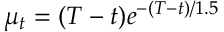<formula> <loc_0><loc_0><loc_500><loc_500>\mu _ { t } = ( T - t ) e ^ { - ( T - t ) / 1 . 5 }</formula> 